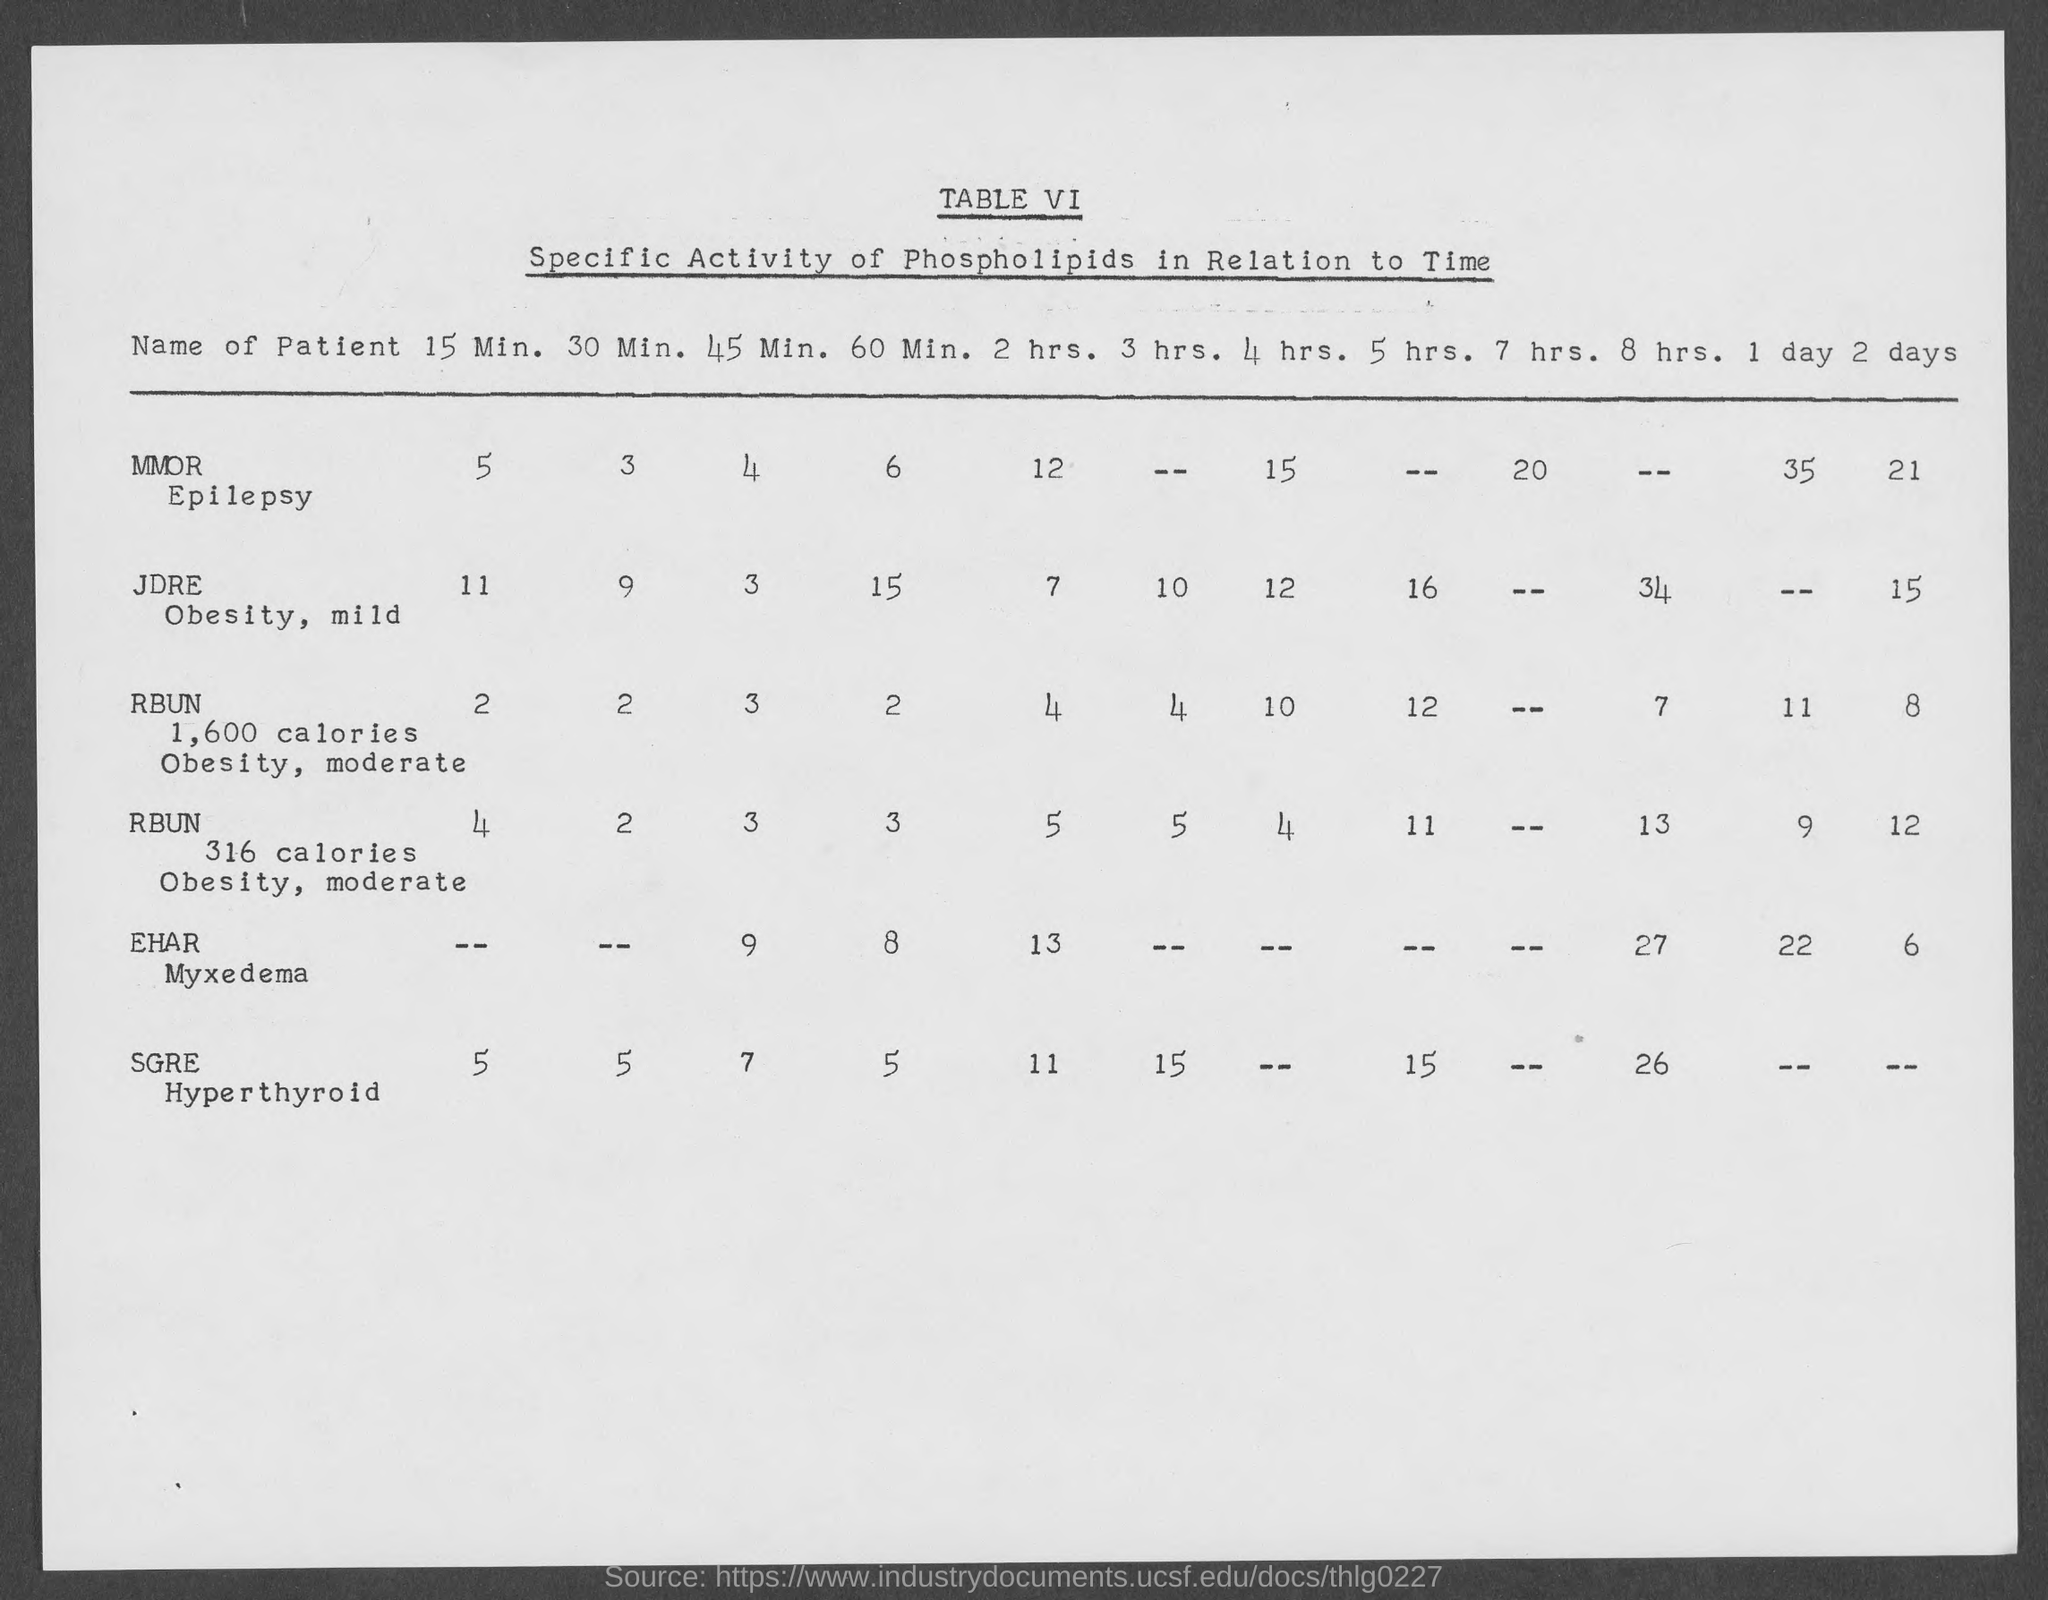Outline some significant characteristics in this image. What is the table number? It is Table VI. 